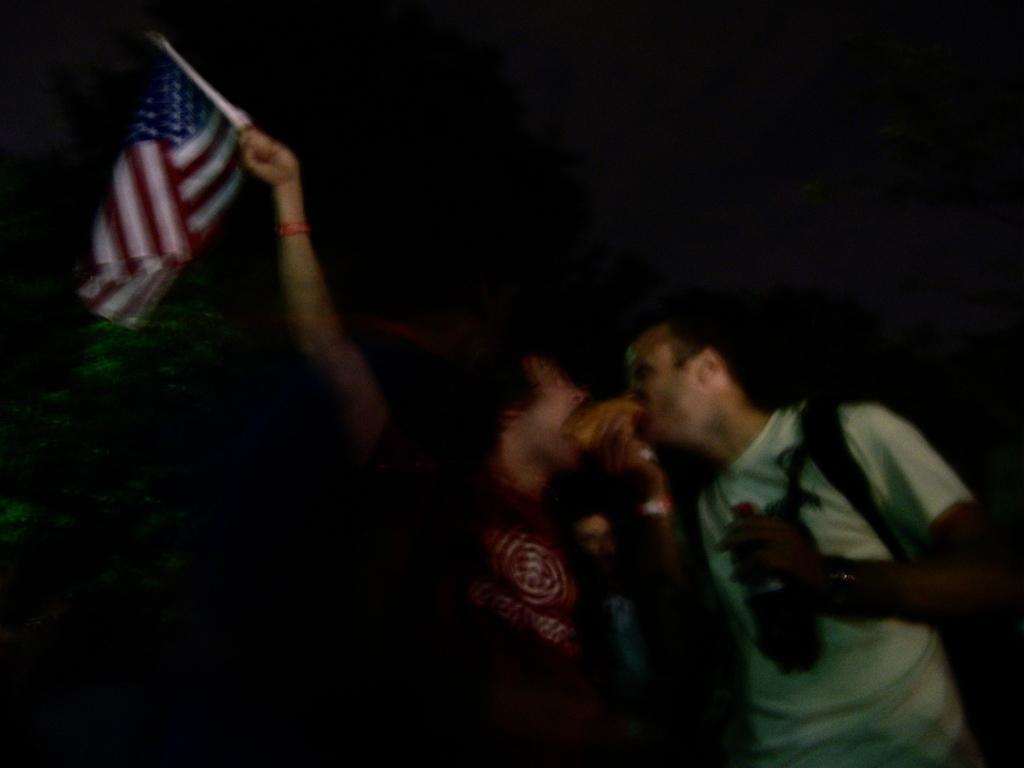Can you describe this image briefly? The picture is blurred. In the foreground of the picture there are men. On the right the person is wearing a backpack and holding a bottle. On the left the person is holding a flag. In the background towards left there is a tree. The background is dark. 